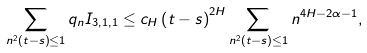<formula> <loc_0><loc_0><loc_500><loc_500>\sum _ { n ^ { 2 } \left ( t - s \right ) \leq 1 } q _ { n } I _ { 3 , 1 , 1 } \leq c _ { H } \left ( t - s \right ) ^ { 2 H } \sum _ { n ^ { 2 } \left ( t - s \right ) \leq 1 } n ^ { 4 H - 2 \alpha - 1 } ,</formula> 